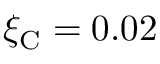<formula> <loc_0><loc_0><loc_500><loc_500>\xi _ { C } = 0 . 0 2</formula> 